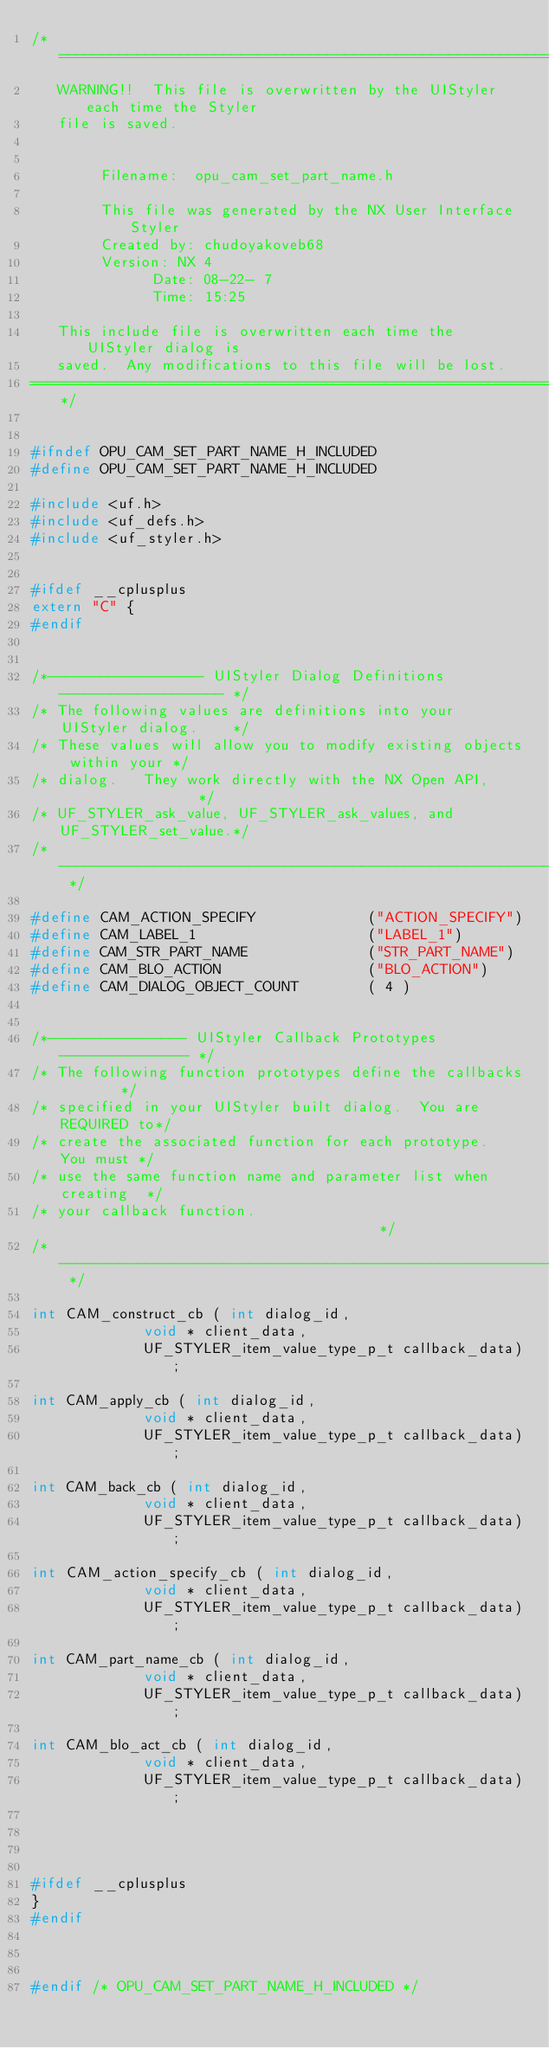<code> <loc_0><loc_0><loc_500><loc_500><_C_>/*=============================================================================
   WARNING!!  This file is overwritten by the UIStyler each time the Styler 
   file is saved.
  
  
        Filename:  opu_cam_set_part_name.h
  
        This file was generated by the NX User Interface Styler
        Created by: chudoyakoveb68
        Version: NX 4
              Date: 08-22- 7
              Time: 15:25
  
   This include file is overwritten each time the UIStyler dialog is
   saved.  Any modifications to this file will be lost.
==============================================================================*/
 
 
#ifndef OPU_CAM_SET_PART_NAME_H_INCLUDED
#define OPU_CAM_SET_PART_NAME_H_INCLUDED
 
#include <uf.h> 
#include <uf_defs.h>
#include <uf_styler.h> 


#ifdef __cplusplus
extern "C" {
#endif


/*------------------ UIStyler Dialog Definitions  ------------------- */
/* The following values are definitions into your UIStyler dialog.    */
/* These values will allow you to modify existing objects within your */
/* dialog.   They work directly with the NX Open API,                 */
/* UF_STYLER_ask_value, UF_STYLER_ask_values, and UF_STYLER_set_value.*/
/*------------------------------------------------------------------- */
 
#define CAM_ACTION_SPECIFY             ("ACTION_SPECIFY")
#define CAM_LABEL_1                    ("LABEL_1")
#define CAM_STR_PART_NAME              ("STR_PART_NAME")
#define CAM_BLO_ACTION                 ("BLO_ACTION")
#define CAM_DIALOG_OBJECT_COUNT        ( 4 )
 

/*---------------- UIStyler Callback Prototypes --------------- */
/* The following function prototypes define the callbacks       */
/* specified in your UIStyler built dialog.  You are REQUIRED to*/
/* create the associated function for each prototype.  You must */
/* use the same function name and parameter list when creating  */
/* your callback function.                                      */
/*------------------------------------------------------------- */

int CAM_construct_cb ( int dialog_id,
             void * client_data,
             UF_STYLER_item_value_type_p_t callback_data);

int CAM_apply_cb ( int dialog_id,
             void * client_data,
             UF_STYLER_item_value_type_p_t callback_data);

int CAM_back_cb ( int dialog_id,
             void * client_data,
             UF_STYLER_item_value_type_p_t callback_data);

int CAM_action_specify_cb ( int dialog_id,
             void * client_data,
             UF_STYLER_item_value_type_p_t callback_data);

int CAM_part_name_cb ( int dialog_id,
             void * client_data,
             UF_STYLER_item_value_type_p_t callback_data);

int CAM_blo_act_cb ( int dialog_id,
             void * client_data,
             UF_STYLER_item_value_type_p_t callback_data);




#ifdef __cplusplus
}
#endif



#endif /* OPU_CAM_SET_PART_NAME_H_INCLUDED */
</code> 